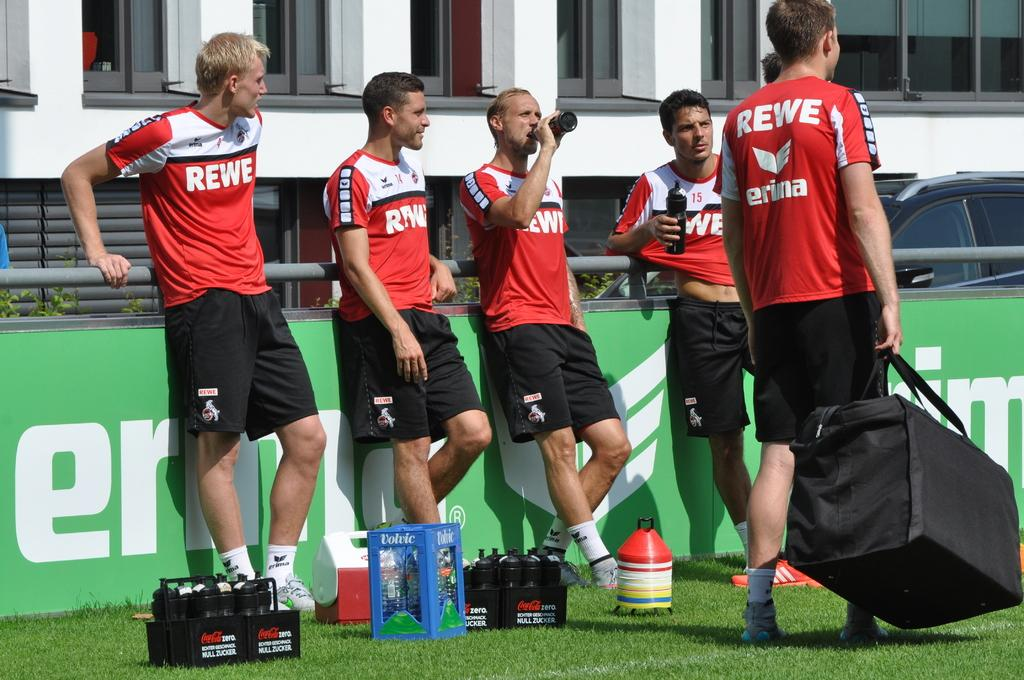<image>
Create a compact narrative representing the image presented. the word rewe is on the back of a shirt 